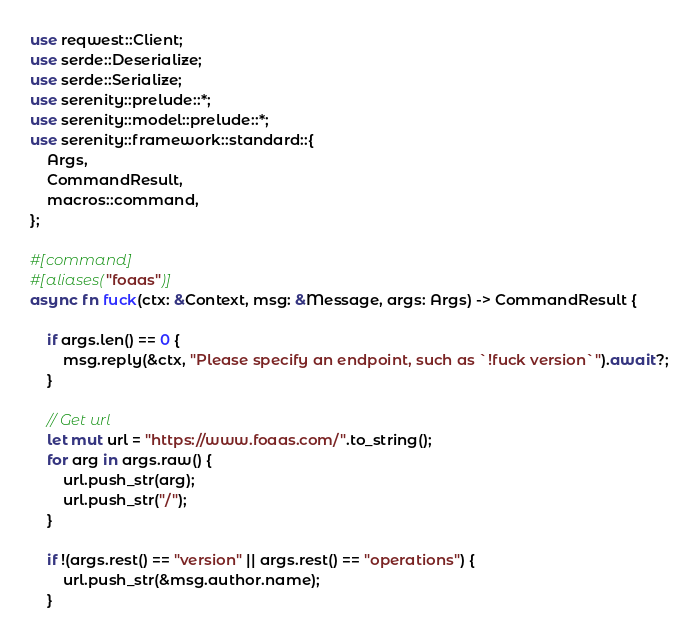<code> <loc_0><loc_0><loc_500><loc_500><_Rust_>use reqwest::Client;
use serde::Deserialize;
use serde::Serialize;
use serenity::prelude::*;
use serenity::model::prelude::*;
use serenity::framework::standard::{
    Args,
    CommandResult,
    macros::command,
};

#[command]
#[aliases("foaas")]
async fn fuck(ctx: &Context, msg: &Message, args: Args) -> CommandResult {

    if args.len() == 0 {
        msg.reply(&ctx, "Please specify an endpoint, such as `!fuck version`").await?;
    }

    // Get url
    let mut url = "https://www.foaas.com/".to_string();
    for arg in args.raw() {
        url.push_str(arg);
        url.push_str("/");
    }
    
    if !(args.rest() == "version" || args.rest() == "operations") {
        url.push_str(&msg.author.name);
    }
</code> 